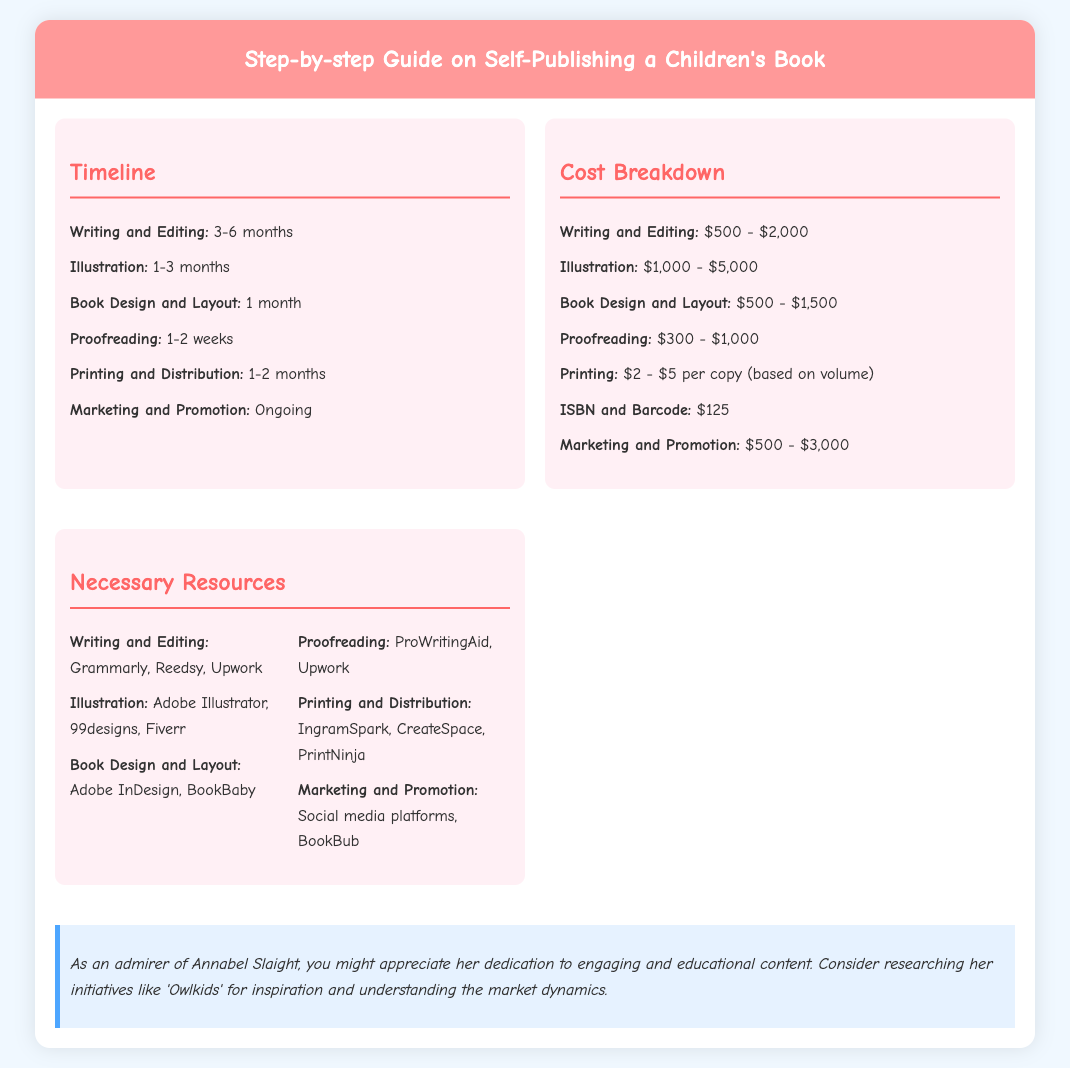what is the time frame for writing and editing? The document states that writing and editing takes 3-6 months.
Answer: 3-6 months what is the cost range for illustration? The cost breakdown lists the range for illustration as $1,000 - $5,000.
Answer: $1,000 - $5,000 how long does proofreading take? The document mentions that proofreading takes 1-2 weeks.
Answer: 1-2 weeks what resource can be used for book design and layout? The document highlights Adobe InDesign as a resource for book design and layout.
Answer: Adobe InDesign list one platform for marketing and promotion. The necessary resources section mentions social media platforms for marketing and promotion.
Answer: Social media platforms what is the total time span for the printing and distribution process? The timeline indicates that printing and distribution takes 1-2 months.
Answer: 1-2 months what is the cost for an ISBN and barcode? The cost breakdown specifies that an ISBN and barcode costs $125.
Answer: $125 how many months should be allocated for book design and layout? The guide states that book design and layout should take 1 month.
Answer: 1 month name a tool for proofreading. The document lists ProWritingAid as a tool for proofreading.
Answer: ProWritingAid 